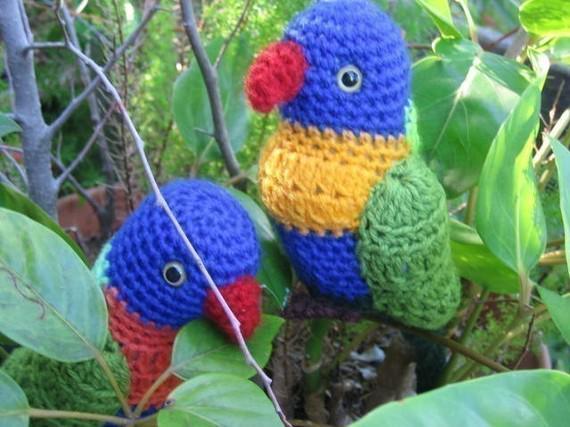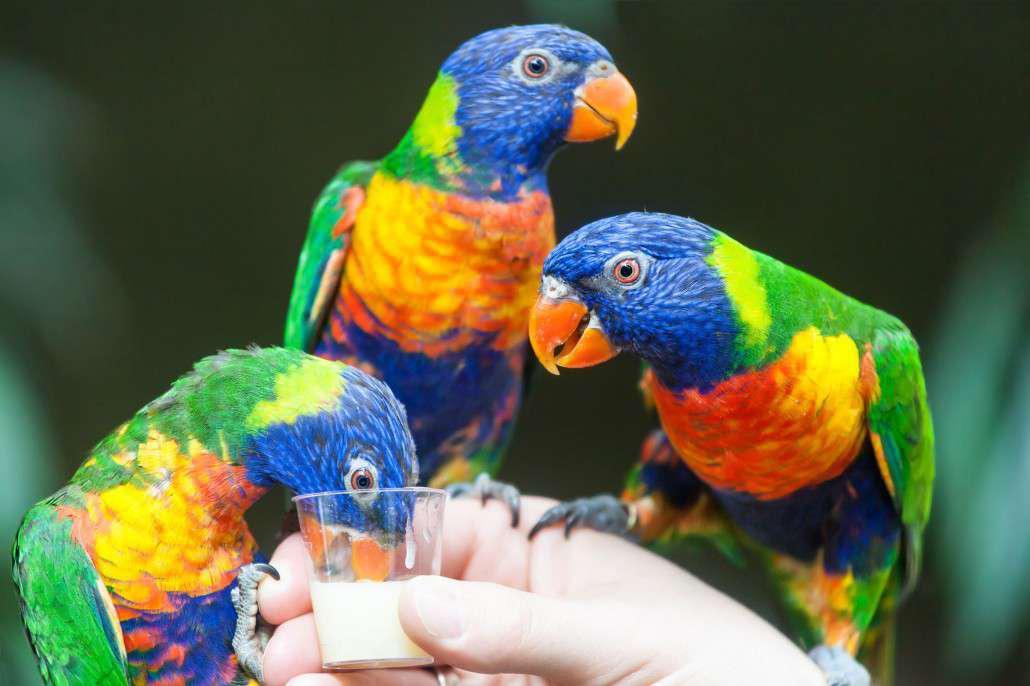The first image is the image on the left, the second image is the image on the right. Considering the images on both sides, is "There are exactly three birds in the image on the right." valid? Answer yes or no. Yes. 